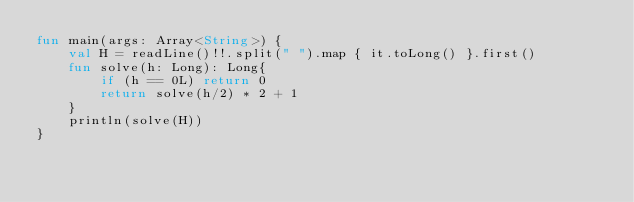Convert code to text. <code><loc_0><loc_0><loc_500><loc_500><_Kotlin_>fun main(args: Array<String>) {
    val H = readLine()!!.split(" ").map { it.toLong() }.first()
    fun solve(h: Long): Long{
        if (h == 0L) return 0
        return solve(h/2) * 2 + 1
    }
    println(solve(H))
}
</code> 